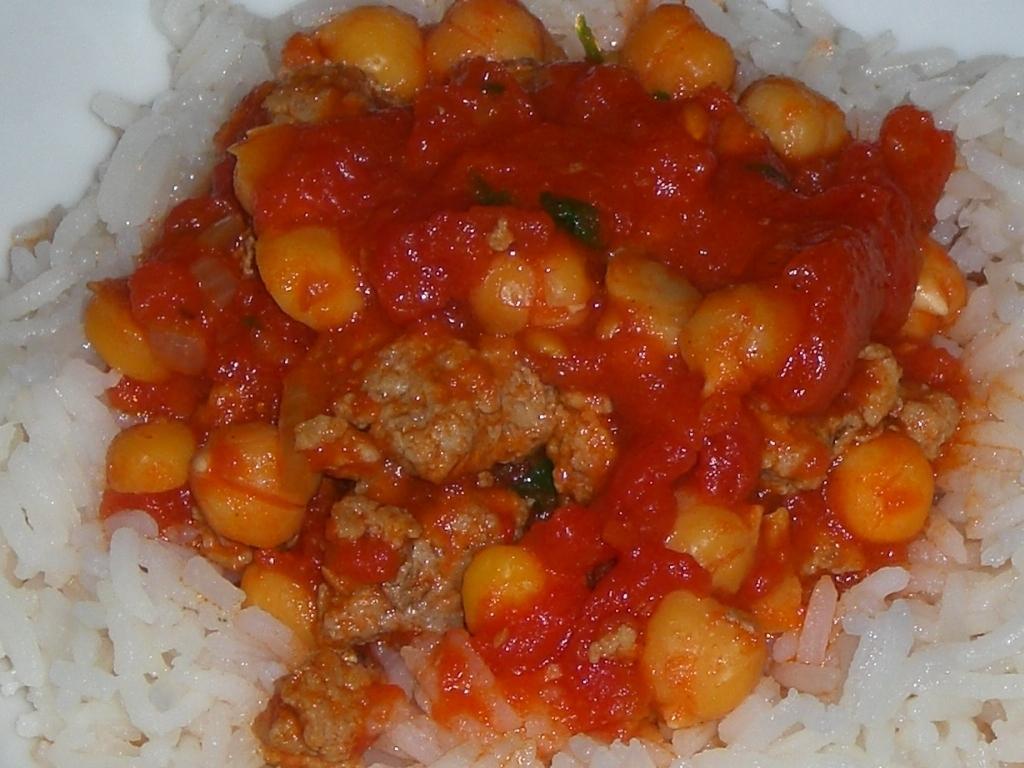How would you summarize this image in a sentence or two? This image consists of rice and curry. Curry is in red color. 